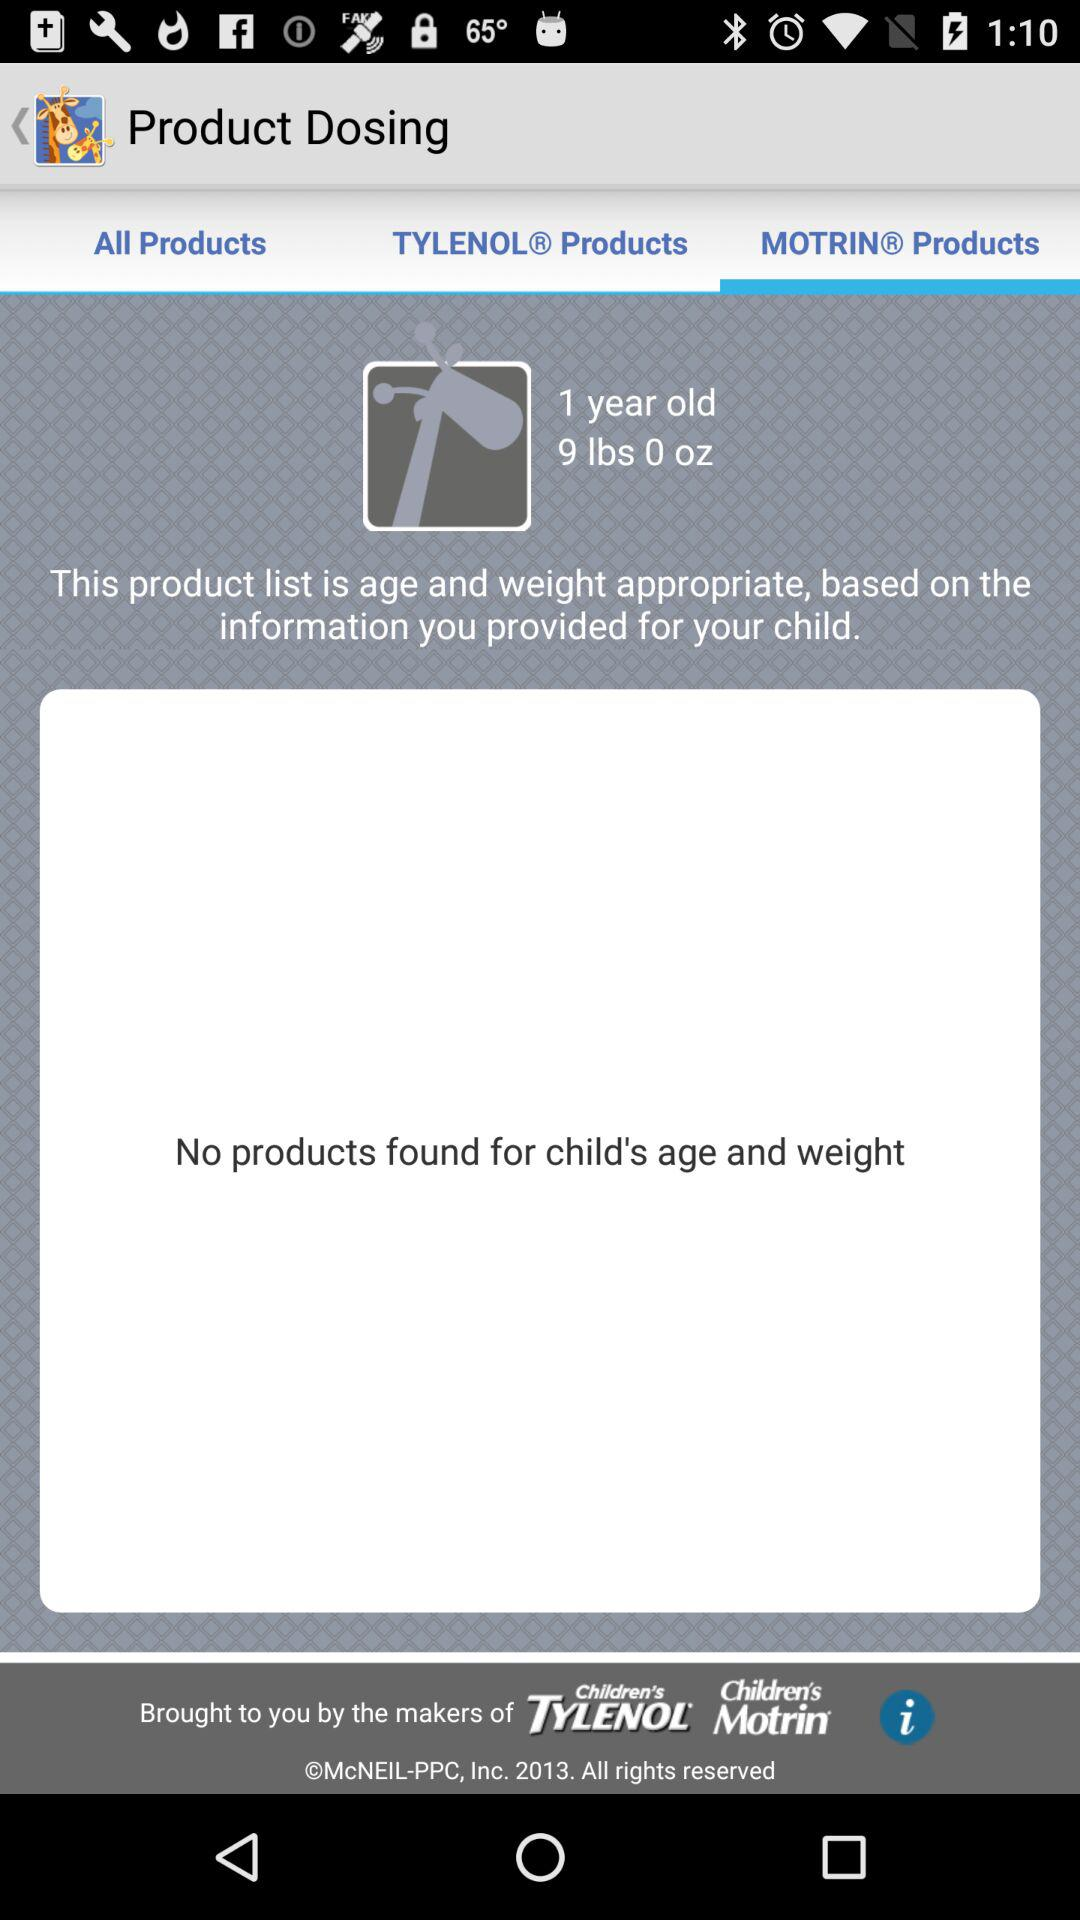How many products have been found? There have been no products found. 